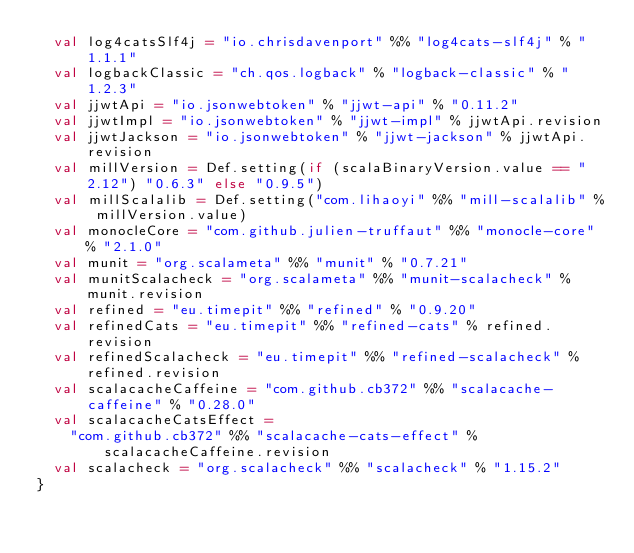<code> <loc_0><loc_0><loc_500><loc_500><_Scala_>  val log4catsSlf4j = "io.chrisdavenport" %% "log4cats-slf4j" % "1.1.1"
  val logbackClassic = "ch.qos.logback" % "logback-classic" % "1.2.3"
  val jjwtApi = "io.jsonwebtoken" % "jjwt-api" % "0.11.2"
  val jjwtImpl = "io.jsonwebtoken" % "jjwt-impl" % jjwtApi.revision
  val jjwtJackson = "io.jsonwebtoken" % "jjwt-jackson" % jjwtApi.revision
  val millVersion = Def.setting(if (scalaBinaryVersion.value == "2.12") "0.6.3" else "0.9.5")
  val millScalalib = Def.setting("com.lihaoyi" %% "mill-scalalib" % millVersion.value)
  val monocleCore = "com.github.julien-truffaut" %% "monocle-core" % "2.1.0"
  val munit = "org.scalameta" %% "munit" % "0.7.21"
  val munitScalacheck = "org.scalameta" %% "munit-scalacheck" % munit.revision
  val refined = "eu.timepit" %% "refined" % "0.9.20"
  val refinedCats = "eu.timepit" %% "refined-cats" % refined.revision
  val refinedScalacheck = "eu.timepit" %% "refined-scalacheck" % refined.revision
  val scalacacheCaffeine = "com.github.cb372" %% "scalacache-caffeine" % "0.28.0"
  val scalacacheCatsEffect =
    "com.github.cb372" %% "scalacache-cats-effect" % scalacacheCaffeine.revision
  val scalacheck = "org.scalacheck" %% "scalacheck" % "1.15.2"
}
</code> 